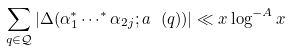<formula> <loc_0><loc_0><loc_500><loc_500>\sum _ { q \in \mathcal { Q } } | \Delta ( \alpha _ { 1 } ^ { * } \cdots ^ { * } \alpha _ { 2 j } ; a \ ( q ) ) | \ll x \log ^ { - A } x</formula> 